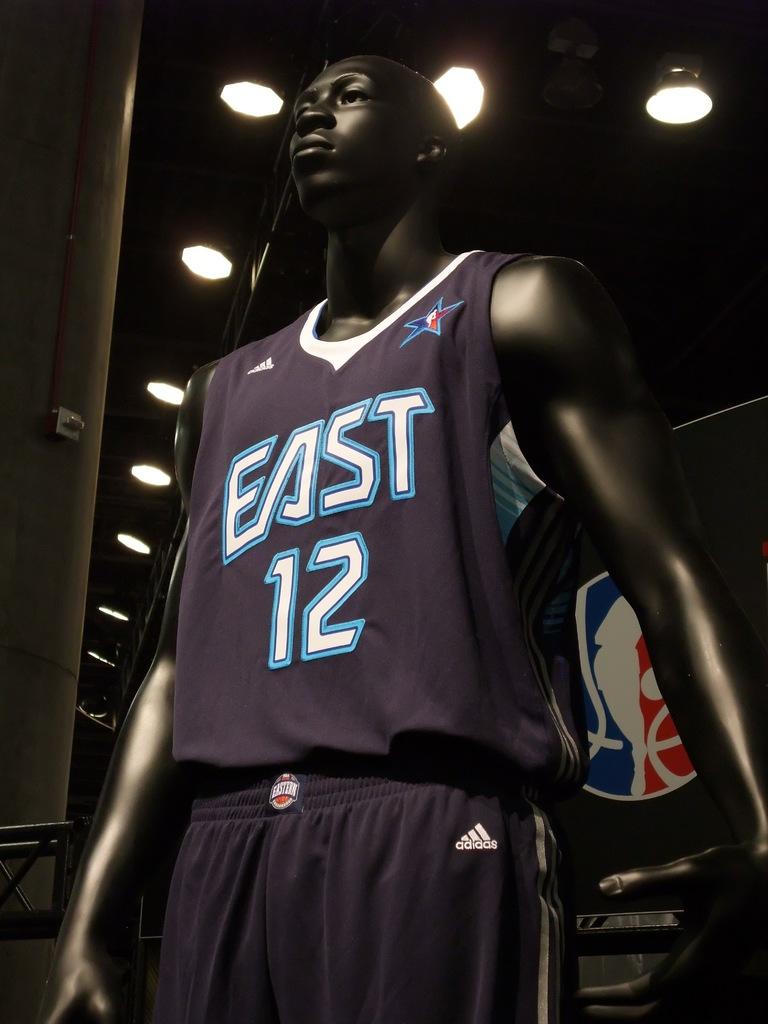What team is this player on?
Your answer should be compact. East. What number is on the shirt?
Make the answer very short. 12. 